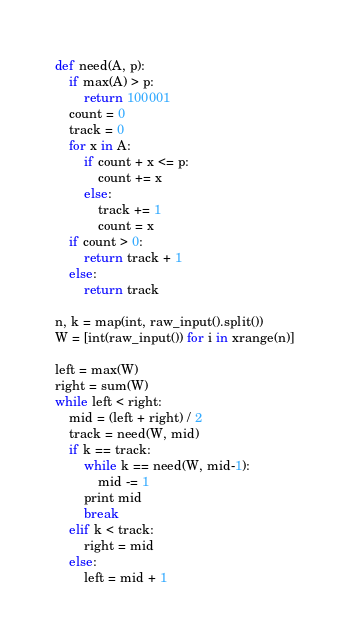<code> <loc_0><loc_0><loc_500><loc_500><_Python_>def need(A, p):
    if max(A) > p:
        return 100001
    count = 0
    track = 0
    for x in A:
        if count + x <= p:
            count += x
        else:
            track += 1
            count = x
    if count > 0:
        return track + 1
    else:
        return track

n, k = map(int, raw_input().split())
W = [int(raw_input()) for i in xrange(n)]

left = max(W)
right = sum(W)
while left < right:
    mid = (left + right) / 2
    track = need(W, mid)
    if k == track:
        while k == need(W, mid-1):
            mid -= 1
        print mid
        break
    elif k < track:
        right = mid
    else:
        left = mid + 1</code> 